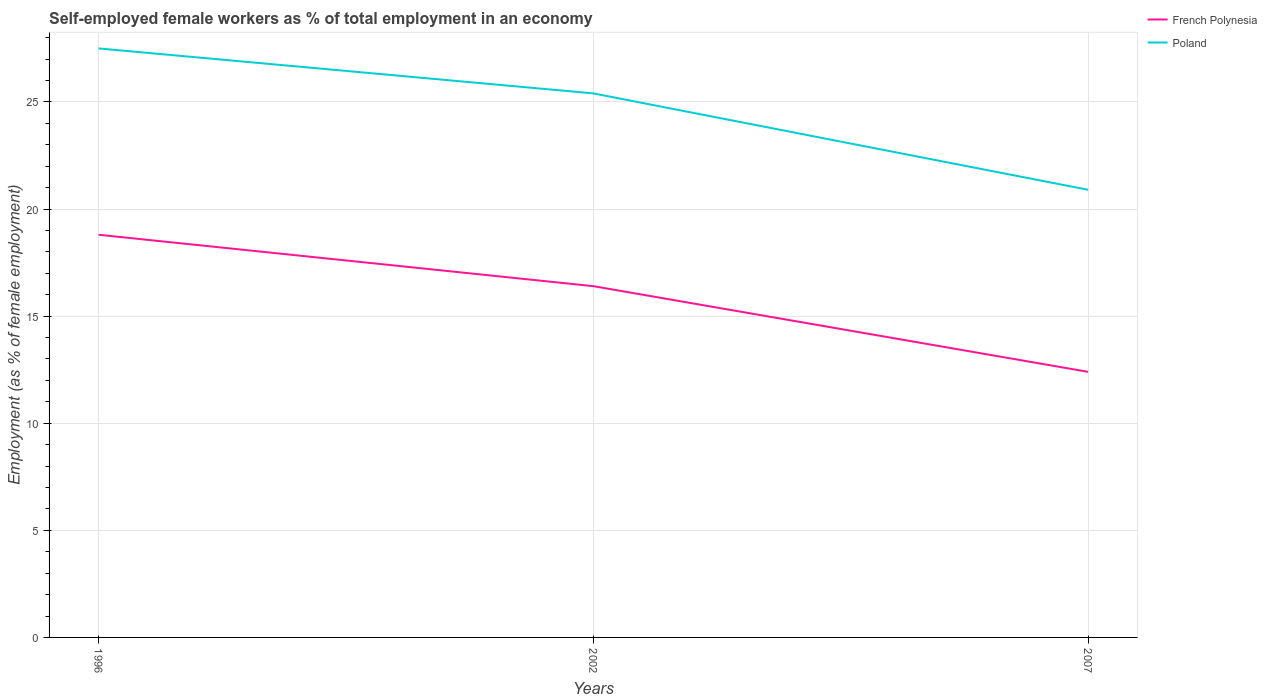Does the line corresponding to Poland intersect with the line corresponding to French Polynesia?
Provide a succinct answer. No. Across all years, what is the maximum percentage of self-employed female workers in French Polynesia?
Your answer should be very brief. 12.4. In which year was the percentage of self-employed female workers in French Polynesia maximum?
Provide a succinct answer. 2007. What is the total percentage of self-employed female workers in Poland in the graph?
Keep it short and to the point. 2.1. What is the difference between the highest and the second highest percentage of self-employed female workers in Poland?
Offer a very short reply. 6.6. How many lines are there?
Give a very brief answer. 2. Are the values on the major ticks of Y-axis written in scientific E-notation?
Provide a succinct answer. No. Does the graph contain any zero values?
Your answer should be compact. No. Where does the legend appear in the graph?
Provide a short and direct response. Top right. How are the legend labels stacked?
Make the answer very short. Vertical. What is the title of the graph?
Offer a very short reply. Self-employed female workers as % of total employment in an economy. Does "Portugal" appear as one of the legend labels in the graph?
Provide a short and direct response. No. What is the label or title of the Y-axis?
Your response must be concise. Employment (as % of female employment). What is the Employment (as % of female employment) of French Polynesia in 1996?
Give a very brief answer. 18.8. What is the Employment (as % of female employment) in Poland in 1996?
Keep it short and to the point. 27.5. What is the Employment (as % of female employment) in French Polynesia in 2002?
Your answer should be very brief. 16.4. What is the Employment (as % of female employment) of Poland in 2002?
Keep it short and to the point. 25.4. What is the Employment (as % of female employment) in French Polynesia in 2007?
Provide a short and direct response. 12.4. What is the Employment (as % of female employment) in Poland in 2007?
Your answer should be very brief. 20.9. Across all years, what is the maximum Employment (as % of female employment) of French Polynesia?
Give a very brief answer. 18.8. Across all years, what is the maximum Employment (as % of female employment) in Poland?
Offer a terse response. 27.5. Across all years, what is the minimum Employment (as % of female employment) in French Polynesia?
Your answer should be very brief. 12.4. Across all years, what is the minimum Employment (as % of female employment) of Poland?
Your answer should be very brief. 20.9. What is the total Employment (as % of female employment) in French Polynesia in the graph?
Provide a succinct answer. 47.6. What is the total Employment (as % of female employment) in Poland in the graph?
Provide a succinct answer. 73.8. What is the average Employment (as % of female employment) in French Polynesia per year?
Your answer should be compact. 15.87. What is the average Employment (as % of female employment) of Poland per year?
Keep it short and to the point. 24.6. In the year 1996, what is the difference between the Employment (as % of female employment) in French Polynesia and Employment (as % of female employment) in Poland?
Offer a terse response. -8.7. In the year 2002, what is the difference between the Employment (as % of female employment) in French Polynesia and Employment (as % of female employment) in Poland?
Keep it short and to the point. -9. What is the ratio of the Employment (as % of female employment) of French Polynesia in 1996 to that in 2002?
Give a very brief answer. 1.15. What is the ratio of the Employment (as % of female employment) in Poland in 1996 to that in 2002?
Make the answer very short. 1.08. What is the ratio of the Employment (as % of female employment) in French Polynesia in 1996 to that in 2007?
Make the answer very short. 1.52. What is the ratio of the Employment (as % of female employment) in Poland in 1996 to that in 2007?
Ensure brevity in your answer.  1.32. What is the ratio of the Employment (as % of female employment) in French Polynesia in 2002 to that in 2007?
Keep it short and to the point. 1.32. What is the ratio of the Employment (as % of female employment) in Poland in 2002 to that in 2007?
Offer a terse response. 1.22. What is the difference between the highest and the second highest Employment (as % of female employment) in Poland?
Your answer should be very brief. 2.1. 